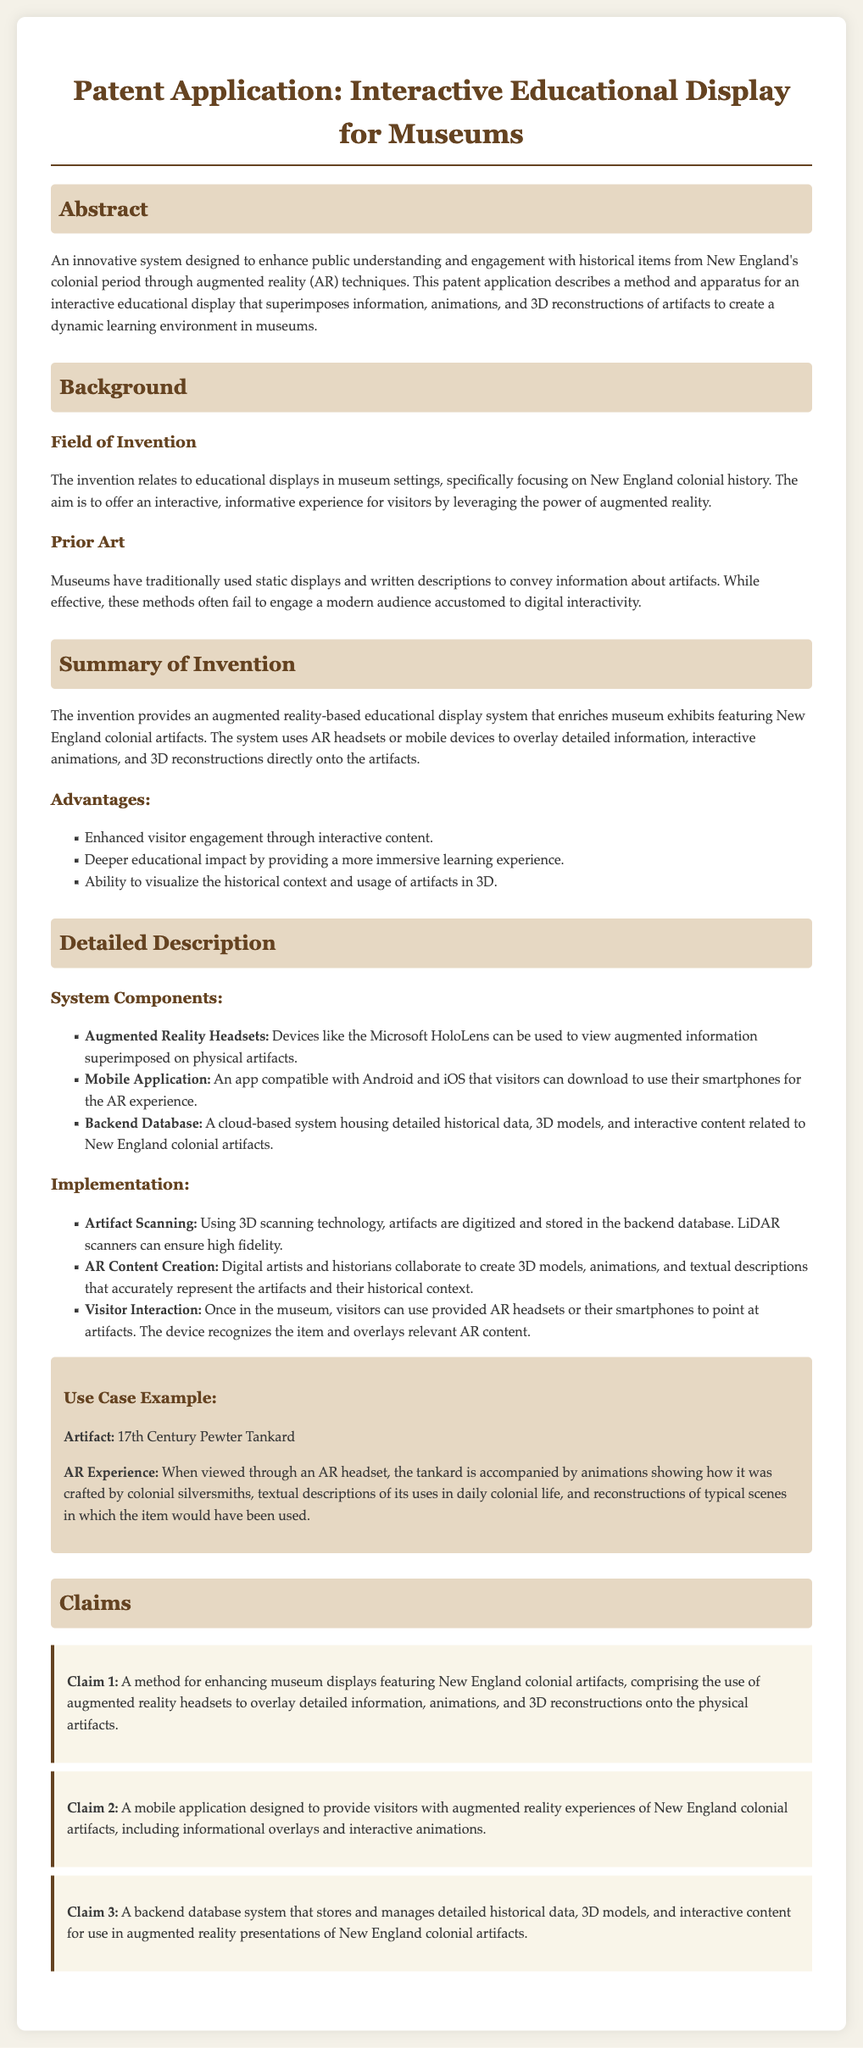What is the field of invention? The field of invention is found in the section titled "Field of Invention," which specifies the focus area of the invention.
Answer: Educational displays in museum settings What technology is used to view augmented information? The document mentions specific devices used for the augmented reality experience in the system components.
Answer: Augmented Reality Headsets What year is the pewter tankard from? The use case example explicitly states the origin year of the pewter tankard.
Answer: 17th Century What is the aim of the invention? The aim is summarized in the abstract, describing the goal of the interactive educational display.
Answer: Enhance public understanding and engagement How many claims are presented in the document? The total number of claims can be counted from the claims section of the document.
Answer: Three 